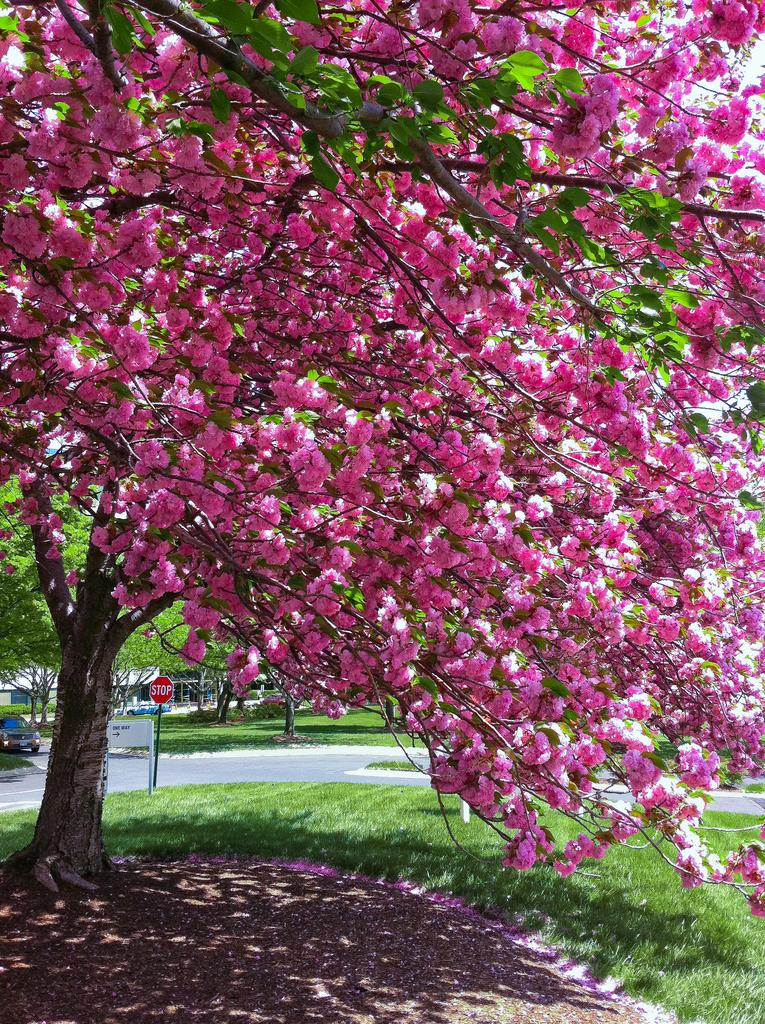What type of vegetation can be seen in the image? There are trees and flowers visible in the image. Where is the car located in the image? The car is on the left side of the image. What type of surface is present at the bottom of the image? There is grass at the bottom of the image. What structure can be seen in the image? There is a building in the image. What type of skirt is being worn by the snow in the image? There is no snow or skirt present in the image. How many cents are visible in the image? There are no cents visible in the image. 